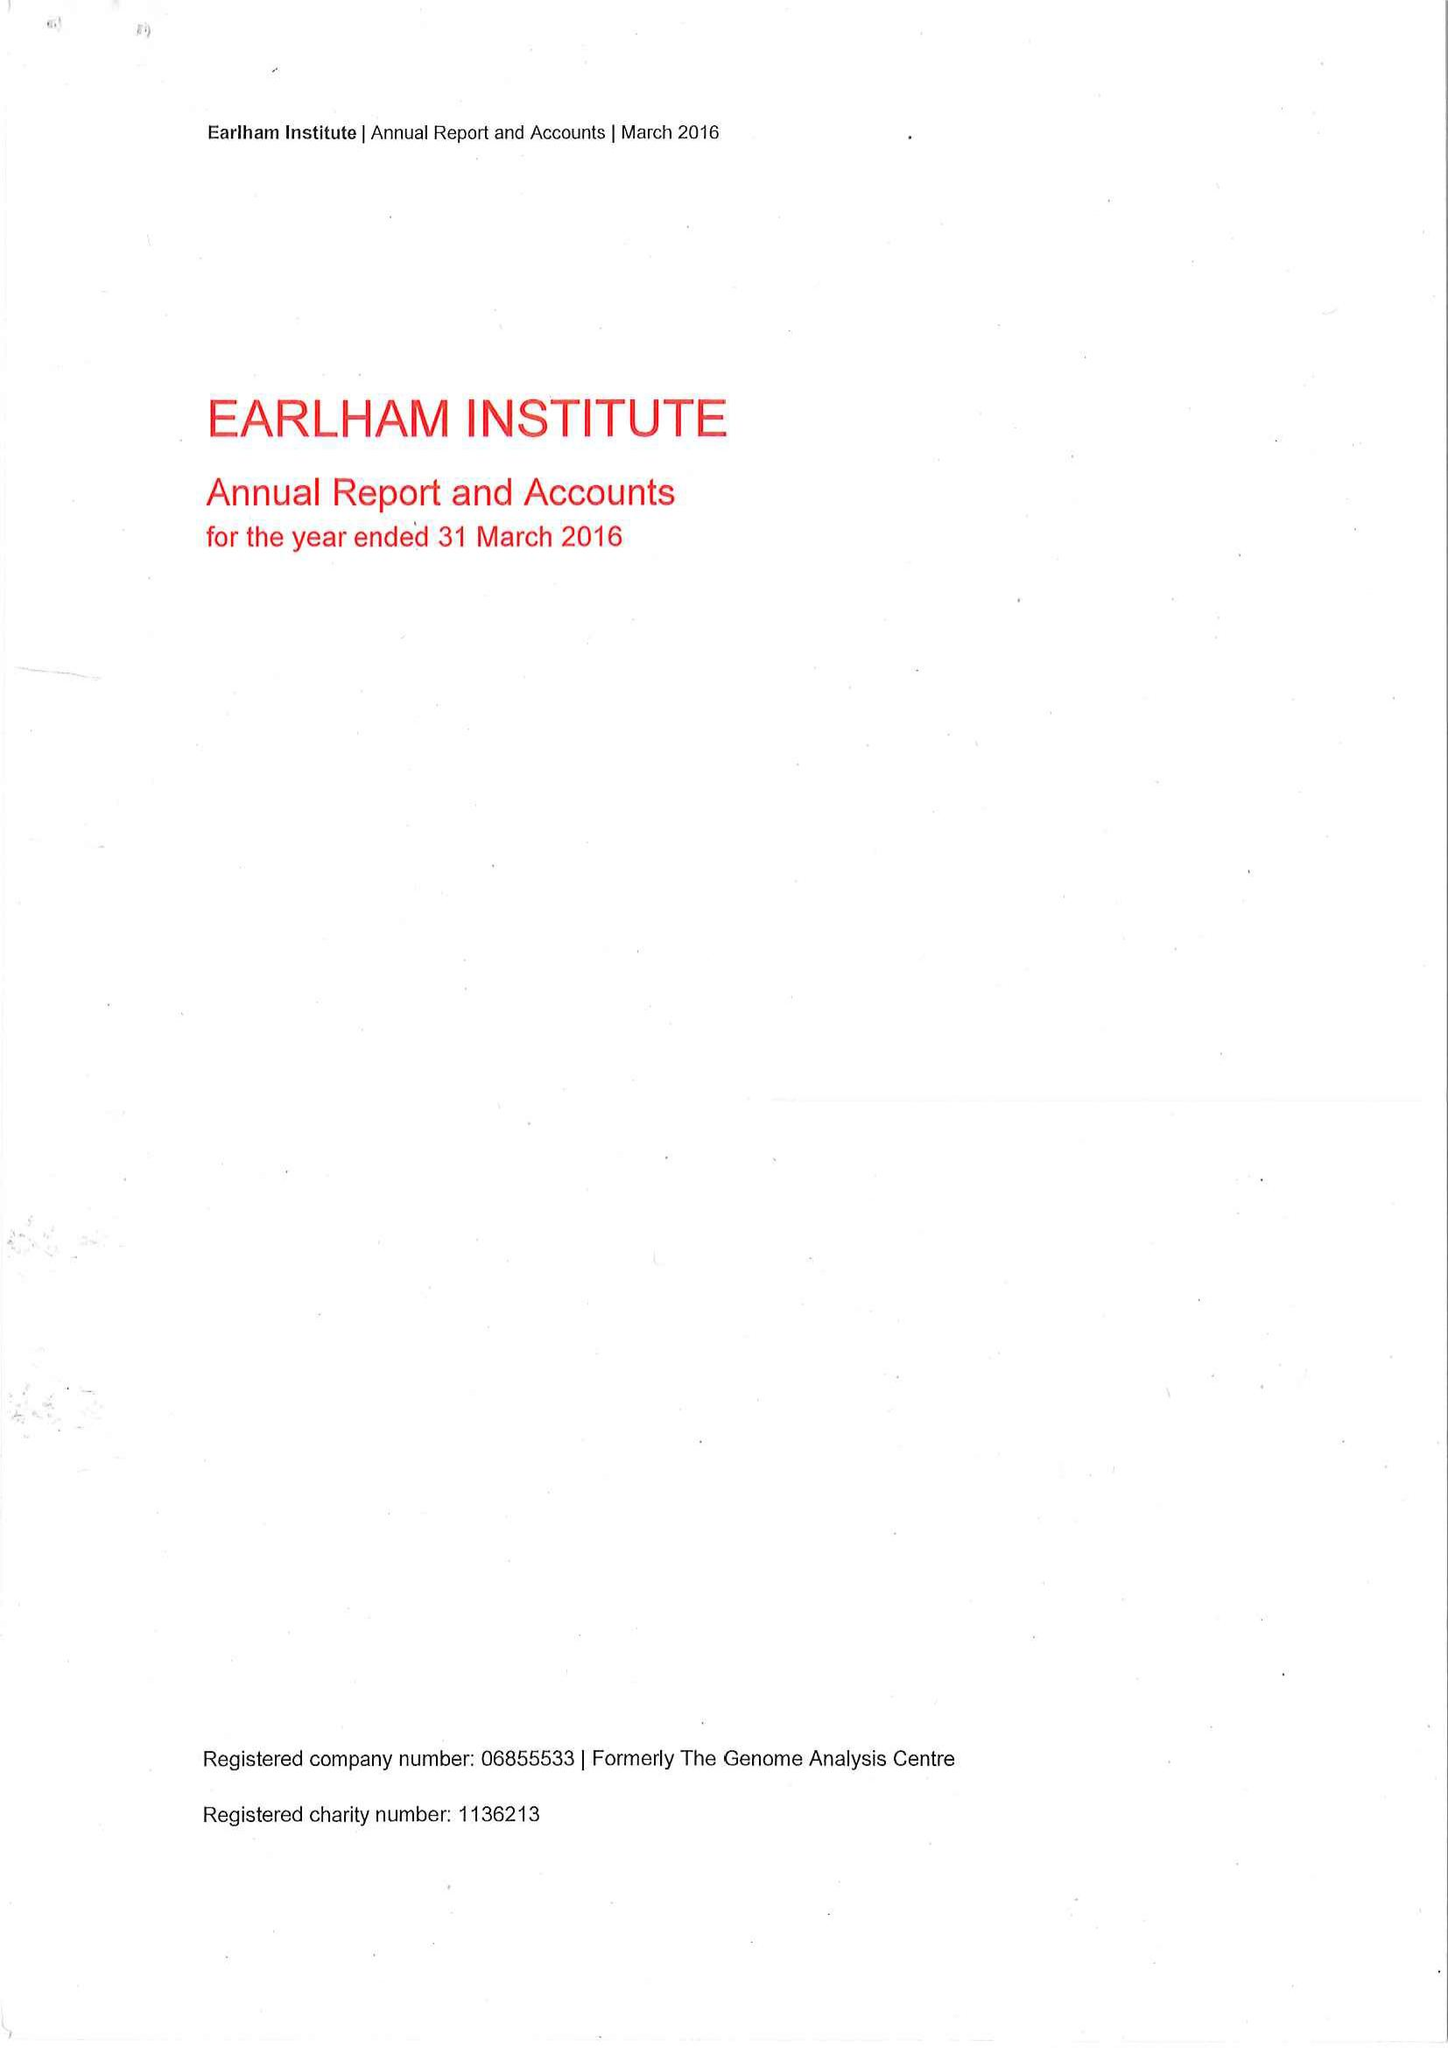What is the value for the address__postcode?
Answer the question using a single word or phrase. NR4 7UZ 